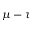<formula> <loc_0><loc_0><loc_500><loc_500>\mu - \tau</formula> 